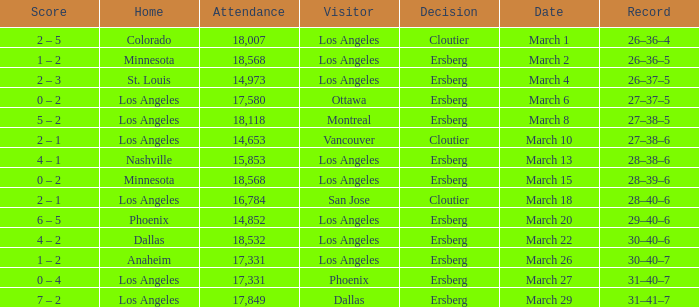On the Date of March 13, who was the Home team? Nashville. 